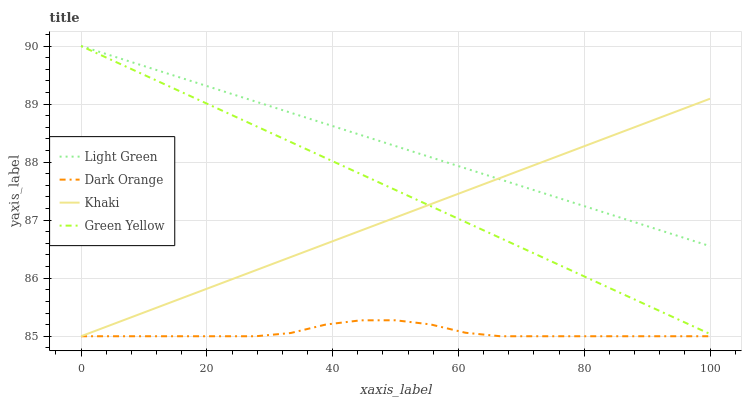Does Dark Orange have the minimum area under the curve?
Answer yes or no. Yes. Does Light Green have the maximum area under the curve?
Answer yes or no. Yes. Does Green Yellow have the minimum area under the curve?
Answer yes or no. No. Does Green Yellow have the maximum area under the curve?
Answer yes or no. No. Is Green Yellow the smoothest?
Answer yes or no. Yes. Is Dark Orange the roughest?
Answer yes or no. Yes. Is Khaki the smoothest?
Answer yes or no. No. Is Khaki the roughest?
Answer yes or no. No. Does Dark Orange have the lowest value?
Answer yes or no. Yes. Does Green Yellow have the lowest value?
Answer yes or no. No. Does Light Green have the highest value?
Answer yes or no. Yes. Does Khaki have the highest value?
Answer yes or no. No. Is Dark Orange less than Green Yellow?
Answer yes or no. Yes. Is Light Green greater than Dark Orange?
Answer yes or no. Yes. Does Khaki intersect Light Green?
Answer yes or no. Yes. Is Khaki less than Light Green?
Answer yes or no. No. Is Khaki greater than Light Green?
Answer yes or no. No. Does Dark Orange intersect Green Yellow?
Answer yes or no. No. 